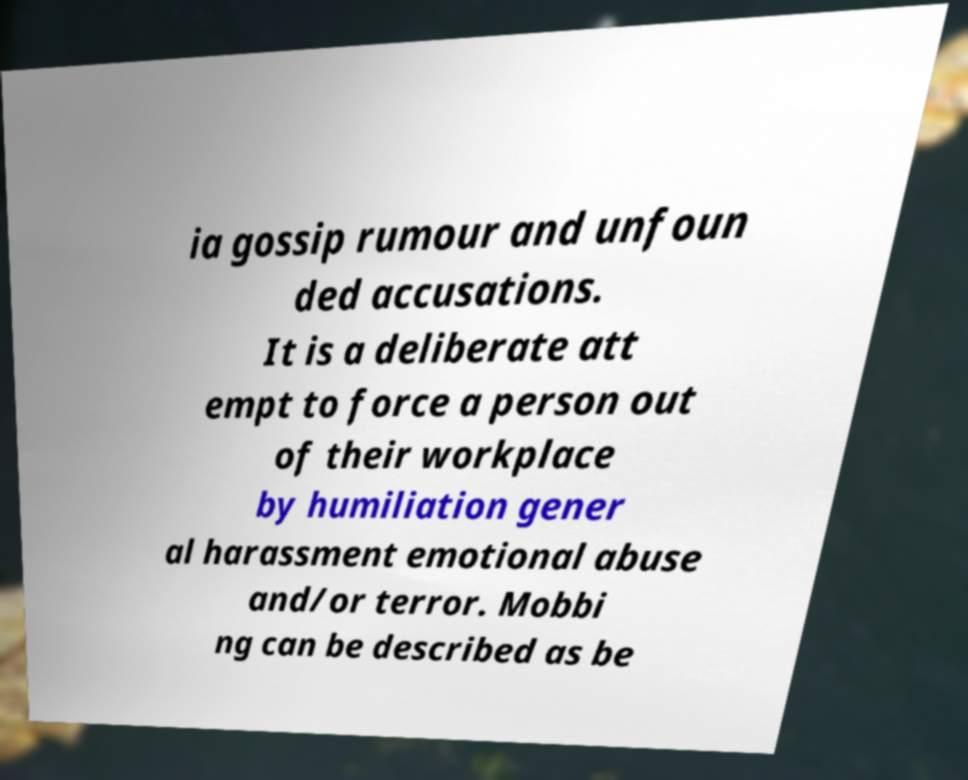Can you read and provide the text displayed in the image?This photo seems to have some interesting text. Can you extract and type it out for me? ia gossip rumour and unfoun ded accusations. It is a deliberate att empt to force a person out of their workplace by humiliation gener al harassment emotional abuse and/or terror. Mobbi ng can be described as be 